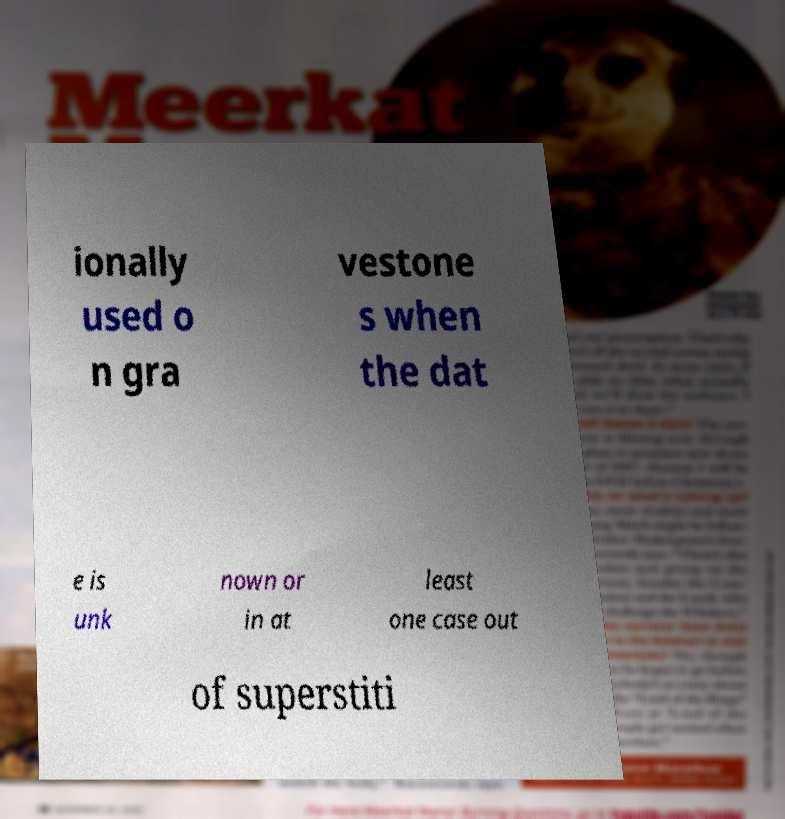There's text embedded in this image that I need extracted. Can you transcribe it verbatim? ionally used o n gra vestone s when the dat e is unk nown or in at least one case out of superstiti 